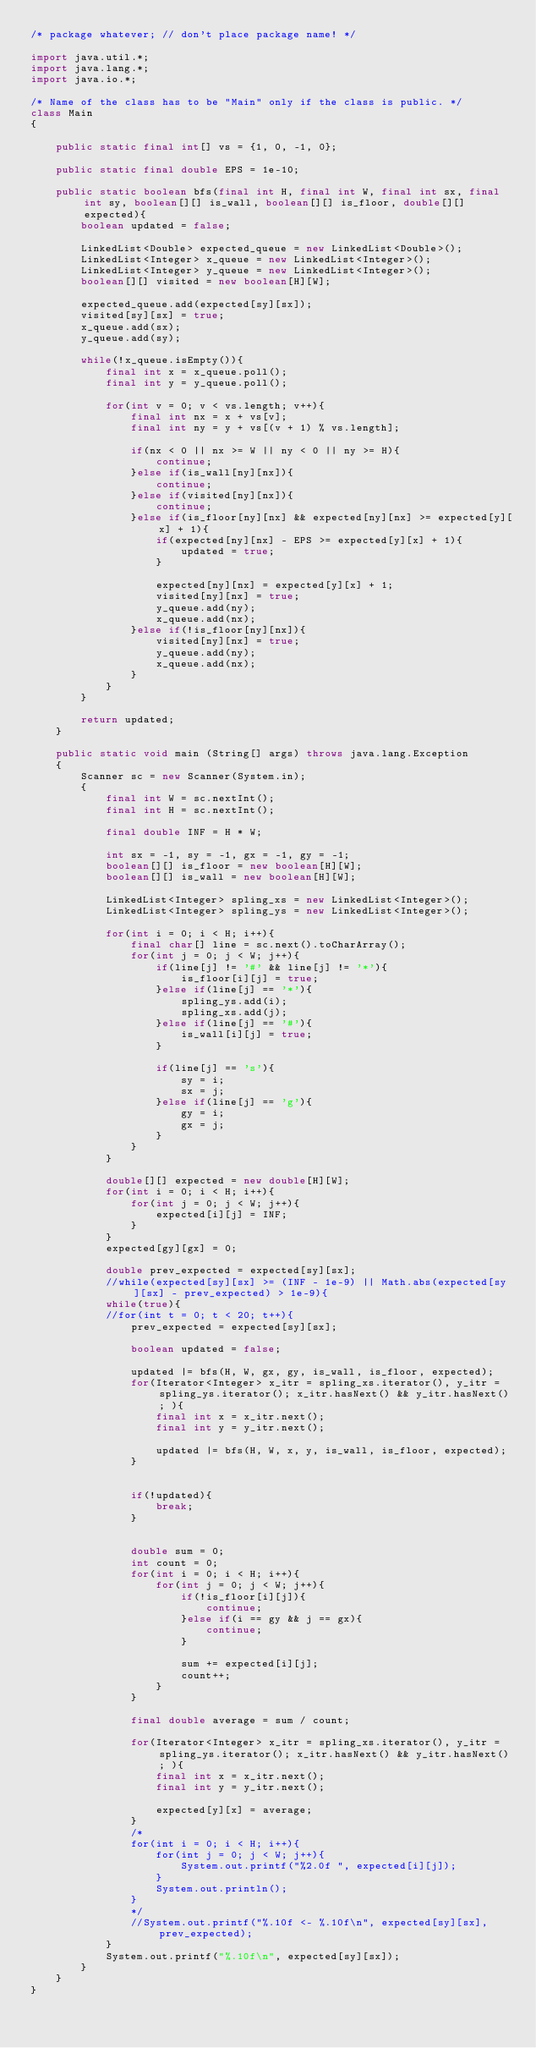<code> <loc_0><loc_0><loc_500><loc_500><_Java_>/* package whatever; // don't place package name! */
 
import java.util.*;
import java.lang.*;
import java.io.*;
 
/* Name of the class has to be "Main" only if the class is public. */
class Main
{
     
    public static final int[] vs = {1, 0, -1, 0};
 
    public static final double EPS = 1e-10;
     
    public static boolean bfs(final int H, final int W, final int sx, final int sy, boolean[][] is_wall, boolean[][] is_floor, double[][] expected){
        boolean updated = false;
         
        LinkedList<Double> expected_queue = new LinkedList<Double>();
        LinkedList<Integer> x_queue = new LinkedList<Integer>();
        LinkedList<Integer> y_queue = new LinkedList<Integer>();
        boolean[][] visited = new boolean[H][W];
         
        expected_queue.add(expected[sy][sx]);
        visited[sy][sx] = true;
        x_queue.add(sx);
        y_queue.add(sy);
         
        while(!x_queue.isEmpty()){
            final int x = x_queue.poll();
            final int y = y_queue.poll();
             
            for(int v = 0; v < vs.length; v++){
                final int nx = x + vs[v];
                final int ny = y + vs[(v + 1) % vs.length];
                 
                if(nx < 0 || nx >= W || ny < 0 || ny >= H){
                    continue;   
                }else if(is_wall[ny][nx]){
                    continue;
                }else if(visited[ny][nx]){
                    continue;
                }else if(is_floor[ny][nx] && expected[ny][nx] >= expected[y][x] + 1){
                    if(expected[ny][nx] - EPS >= expected[y][x] + 1){
                        updated = true;
                    }
                     
                    expected[ny][nx] = expected[y][x] + 1;
                    visited[ny][nx] = true;
                    y_queue.add(ny);
                    x_queue.add(nx);
                }else if(!is_floor[ny][nx]){
                    visited[ny][nx] = true;
                    y_queue.add(ny);
                    x_queue.add(nx);
                }
            }
        }
         
        return updated;
    }
     
    public static void main (String[] args) throws java.lang.Exception
    {
        Scanner sc = new Scanner(System.in);
        {
            final int W = sc.nextInt();
            final int H = sc.nextInt();
             
            final double INF = H * W;
             
            int sx = -1, sy = -1, gx = -1, gy = -1;
            boolean[][] is_floor = new boolean[H][W];
            boolean[][] is_wall = new boolean[H][W];
             
            LinkedList<Integer> spling_xs = new LinkedList<Integer>();
            LinkedList<Integer> spling_ys = new LinkedList<Integer>();
             
            for(int i = 0; i < H; i++){
                final char[] line = sc.next().toCharArray();
                for(int j = 0; j < W; j++){
                    if(line[j] != '#' && line[j] != '*'){
                        is_floor[i][j] = true;
                    }else if(line[j] == '*'){
                        spling_ys.add(i);
                        spling_xs.add(j);
                    }else if(line[j] == '#'){
                        is_wall[i][j] = true;
                    }
                     
                    if(line[j] == 's'){
                        sy = i;
                        sx = j;
                    }else if(line[j] == 'g'){
                        gy = i;
                        gx = j;
                    }
                }
            }
             
            double[][] expected = new double[H][W];
            for(int i = 0; i < H; i++){
                for(int j = 0; j < W; j++){
                    expected[i][j] = INF;
                }
            }
            expected[gy][gx] = 0;
             
            double prev_expected = expected[sy][sx];
            //while(expected[sy][sx] >= (INF - 1e-9) || Math.abs(expected[sy][sx] - prev_expected) > 1e-9){
            while(true){
            //for(int t = 0; t < 20; t++){
                prev_expected = expected[sy][sx];
                 
                boolean updated = false;
                 
                updated |= bfs(H, W, gx, gy, is_wall, is_floor, expected);
                for(Iterator<Integer> x_itr = spling_xs.iterator(), y_itr = spling_ys.iterator(); x_itr.hasNext() && y_itr.hasNext(); ){
                    final int x = x_itr.next();
                    final int y = y_itr.next();
                     
                    updated |= bfs(H, W, x, y, is_wall, is_floor, expected);
                }
                 
                 
                if(!updated){
                    break;
                }
                 
                 
                double sum = 0;
                int count = 0;
                for(int i = 0; i < H; i++){
                    for(int j = 0; j < W; j++){
                        if(!is_floor[i][j]){
                            continue;
                        }else if(i == gy && j == gx){
                            continue;
                        }
                         
                        sum += expected[i][j];
                        count++;
                    }
                }
                 
                final double average = sum / count;
                 
                for(Iterator<Integer> x_itr = spling_xs.iterator(), y_itr = spling_ys.iterator(); x_itr.hasNext() && y_itr.hasNext(); ){
                    final int x = x_itr.next();
                    final int y = y_itr.next();
                     
                    expected[y][x] = average;
                }
                /*
                for(int i = 0; i < H; i++){
                    for(int j = 0; j < W; j++){
                        System.out.printf("%2.0f ", expected[i][j]);
                    }
                    System.out.println();
                }
                */
                //System.out.printf("%.10f <- %.10f\n", expected[sy][sx], prev_expected);
            }
            System.out.printf("%.10f\n", expected[sy][sx]);
        }
    }
}</code> 